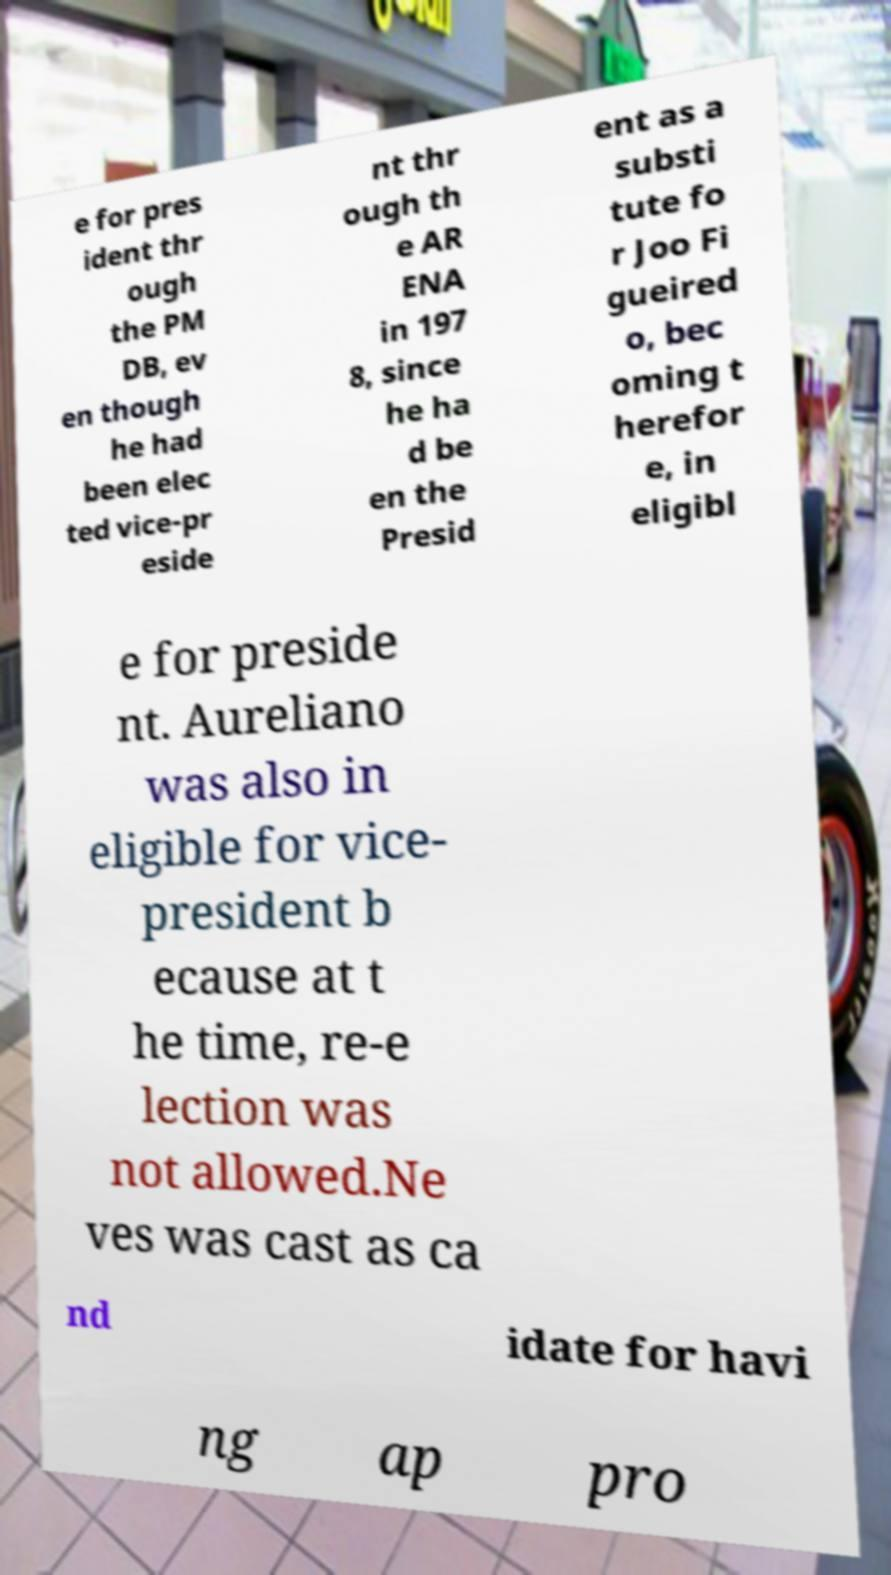Please identify and transcribe the text found in this image. e for pres ident thr ough the PM DB, ev en though he had been elec ted vice-pr eside nt thr ough th e AR ENA in 197 8, since he ha d be en the Presid ent as a substi tute fo r Joo Fi gueired o, bec oming t herefor e, in eligibl e for preside nt. Aureliano was also in eligible for vice- president b ecause at t he time, re-e lection was not allowed.Ne ves was cast as ca nd idate for havi ng ap pro 